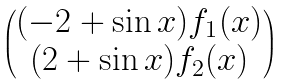Convert formula to latex. <formula><loc_0><loc_0><loc_500><loc_500>\begin{pmatrix} ( - 2 + \sin x ) f _ { 1 } ( x ) \\ ( 2 + \sin x ) f _ { 2 } ( x ) \end{pmatrix}</formula> 